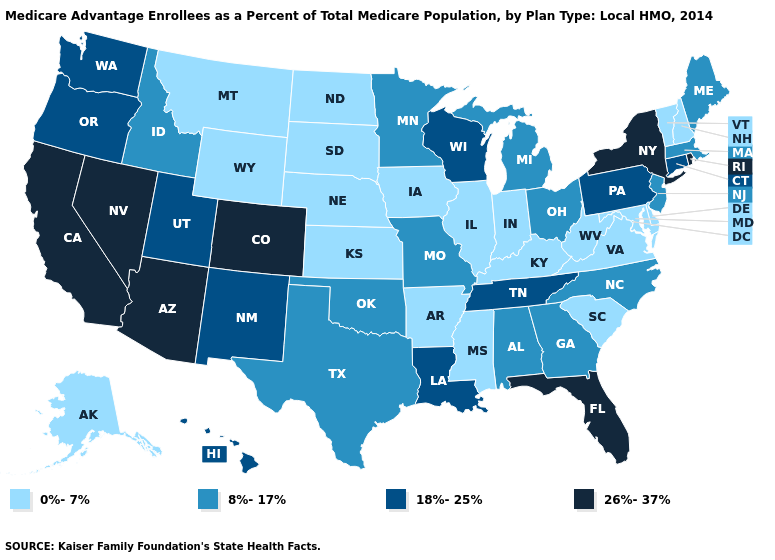What is the value of Hawaii?
Short answer required. 18%-25%. What is the value of Ohio?
Be succinct. 8%-17%. Does Indiana have the lowest value in the MidWest?
Concise answer only. Yes. What is the value of Indiana?
Be succinct. 0%-7%. What is the value of Washington?
Short answer required. 18%-25%. Does Minnesota have the lowest value in the MidWest?
Give a very brief answer. No. What is the value of West Virginia?
Quick response, please. 0%-7%. Name the states that have a value in the range 8%-17%?
Keep it brief. Alabama, Georgia, Idaho, Massachusetts, Maine, Michigan, Minnesota, Missouri, North Carolina, New Jersey, Ohio, Oklahoma, Texas. What is the value of West Virginia?
Short answer required. 0%-7%. What is the value of Vermont?
Concise answer only. 0%-7%. Name the states that have a value in the range 0%-7%?
Give a very brief answer. Alaska, Arkansas, Delaware, Iowa, Illinois, Indiana, Kansas, Kentucky, Maryland, Mississippi, Montana, North Dakota, Nebraska, New Hampshire, South Carolina, South Dakota, Virginia, Vermont, West Virginia, Wyoming. Name the states that have a value in the range 8%-17%?
Write a very short answer. Alabama, Georgia, Idaho, Massachusetts, Maine, Michigan, Minnesota, Missouri, North Carolina, New Jersey, Ohio, Oklahoma, Texas. What is the lowest value in the USA?
Concise answer only. 0%-7%. Name the states that have a value in the range 18%-25%?
Concise answer only. Connecticut, Hawaii, Louisiana, New Mexico, Oregon, Pennsylvania, Tennessee, Utah, Washington, Wisconsin. Name the states that have a value in the range 8%-17%?
Keep it brief. Alabama, Georgia, Idaho, Massachusetts, Maine, Michigan, Minnesota, Missouri, North Carolina, New Jersey, Ohio, Oklahoma, Texas. 